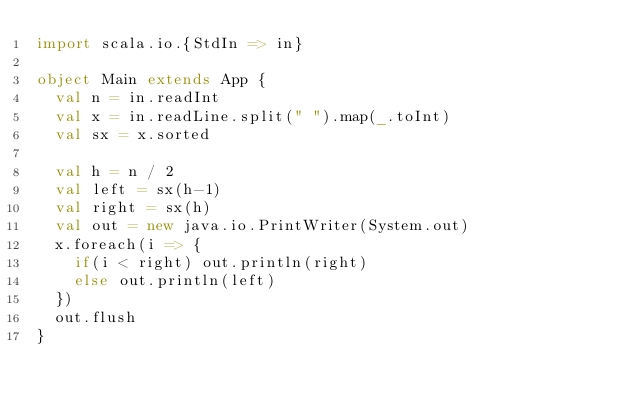Convert code to text. <code><loc_0><loc_0><loc_500><loc_500><_Scala_>import scala.io.{StdIn => in}

object Main extends App {
  val n = in.readInt
  val x = in.readLine.split(" ").map(_.toInt)
  val sx = x.sorted

  val h = n / 2
  val left = sx(h-1)
  val right = sx(h)
  val out = new java.io.PrintWriter(System.out)
  x.foreach(i => {
    if(i < right) out.println(right)
    else out.println(left)
  })
  out.flush
}</code> 